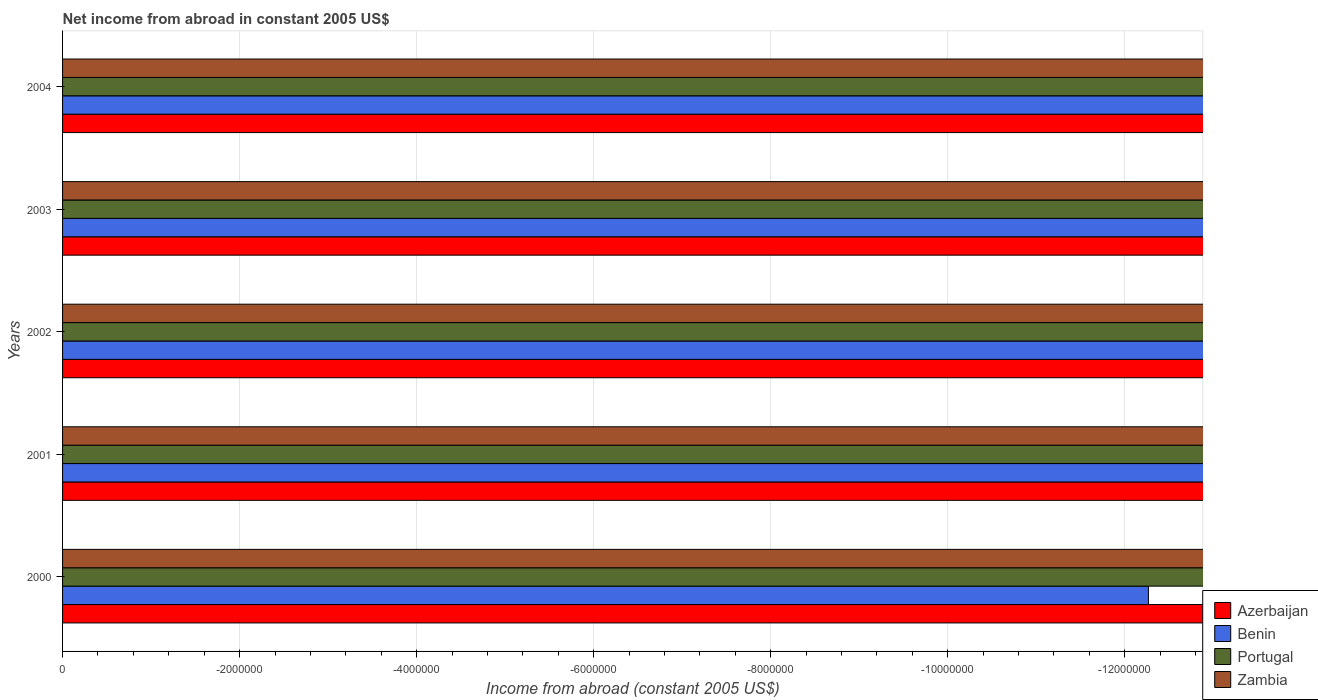How many different coloured bars are there?
Offer a terse response. 0. Are the number of bars per tick equal to the number of legend labels?
Provide a short and direct response. No. Are the number of bars on each tick of the Y-axis equal?
Provide a succinct answer. Yes. How many bars are there on the 1st tick from the top?
Keep it short and to the point. 0. What is the label of the 1st group of bars from the top?
Your response must be concise. 2004. What is the difference between the net income from abroad in Zambia in 2001 and the net income from abroad in Portugal in 2002?
Your answer should be very brief. 0. What is the average net income from abroad in Zambia per year?
Provide a succinct answer. 0. In how many years, is the net income from abroad in Benin greater than -9200000 US$?
Your response must be concise. 0. In how many years, is the net income from abroad in Benin greater than the average net income from abroad in Benin taken over all years?
Offer a very short reply. 0. How many bars are there?
Offer a very short reply. 0. Does the graph contain any zero values?
Your answer should be compact. Yes. What is the title of the graph?
Your answer should be compact. Net income from abroad in constant 2005 US$. Does "Maldives" appear as one of the legend labels in the graph?
Give a very brief answer. No. What is the label or title of the X-axis?
Keep it short and to the point. Income from abroad (constant 2005 US$). What is the Income from abroad (constant 2005 US$) in Benin in 2000?
Give a very brief answer. 0. What is the Income from abroad (constant 2005 US$) in Portugal in 2000?
Keep it short and to the point. 0. What is the Income from abroad (constant 2005 US$) in Azerbaijan in 2001?
Offer a terse response. 0. What is the Income from abroad (constant 2005 US$) of Benin in 2001?
Your response must be concise. 0. What is the Income from abroad (constant 2005 US$) of Azerbaijan in 2003?
Make the answer very short. 0. What is the Income from abroad (constant 2005 US$) of Zambia in 2003?
Your answer should be compact. 0. What is the Income from abroad (constant 2005 US$) of Azerbaijan in 2004?
Give a very brief answer. 0. What is the total Income from abroad (constant 2005 US$) in Azerbaijan in the graph?
Your answer should be very brief. 0. What is the total Income from abroad (constant 2005 US$) in Portugal in the graph?
Ensure brevity in your answer.  0. What is the average Income from abroad (constant 2005 US$) of Benin per year?
Keep it short and to the point. 0. What is the average Income from abroad (constant 2005 US$) of Portugal per year?
Your answer should be very brief. 0. What is the average Income from abroad (constant 2005 US$) of Zambia per year?
Provide a succinct answer. 0. 